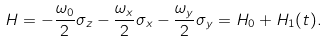Convert formula to latex. <formula><loc_0><loc_0><loc_500><loc_500>H = - { \frac { \omega _ { 0 } } { 2 } } \sigma _ { z } - { \frac { \omega _ { x } } { 2 } } \sigma _ { x } - { \frac { \omega _ { y } } { 2 } } \sigma _ { y } = H _ { 0 } + H _ { 1 } ( t ) .</formula> 